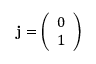Convert formula to latex. <formula><loc_0><loc_0><loc_500><loc_500>j = { \left ( \begin{array} { l } { 0 } \\ { 1 } \end{array} \right ) }</formula> 